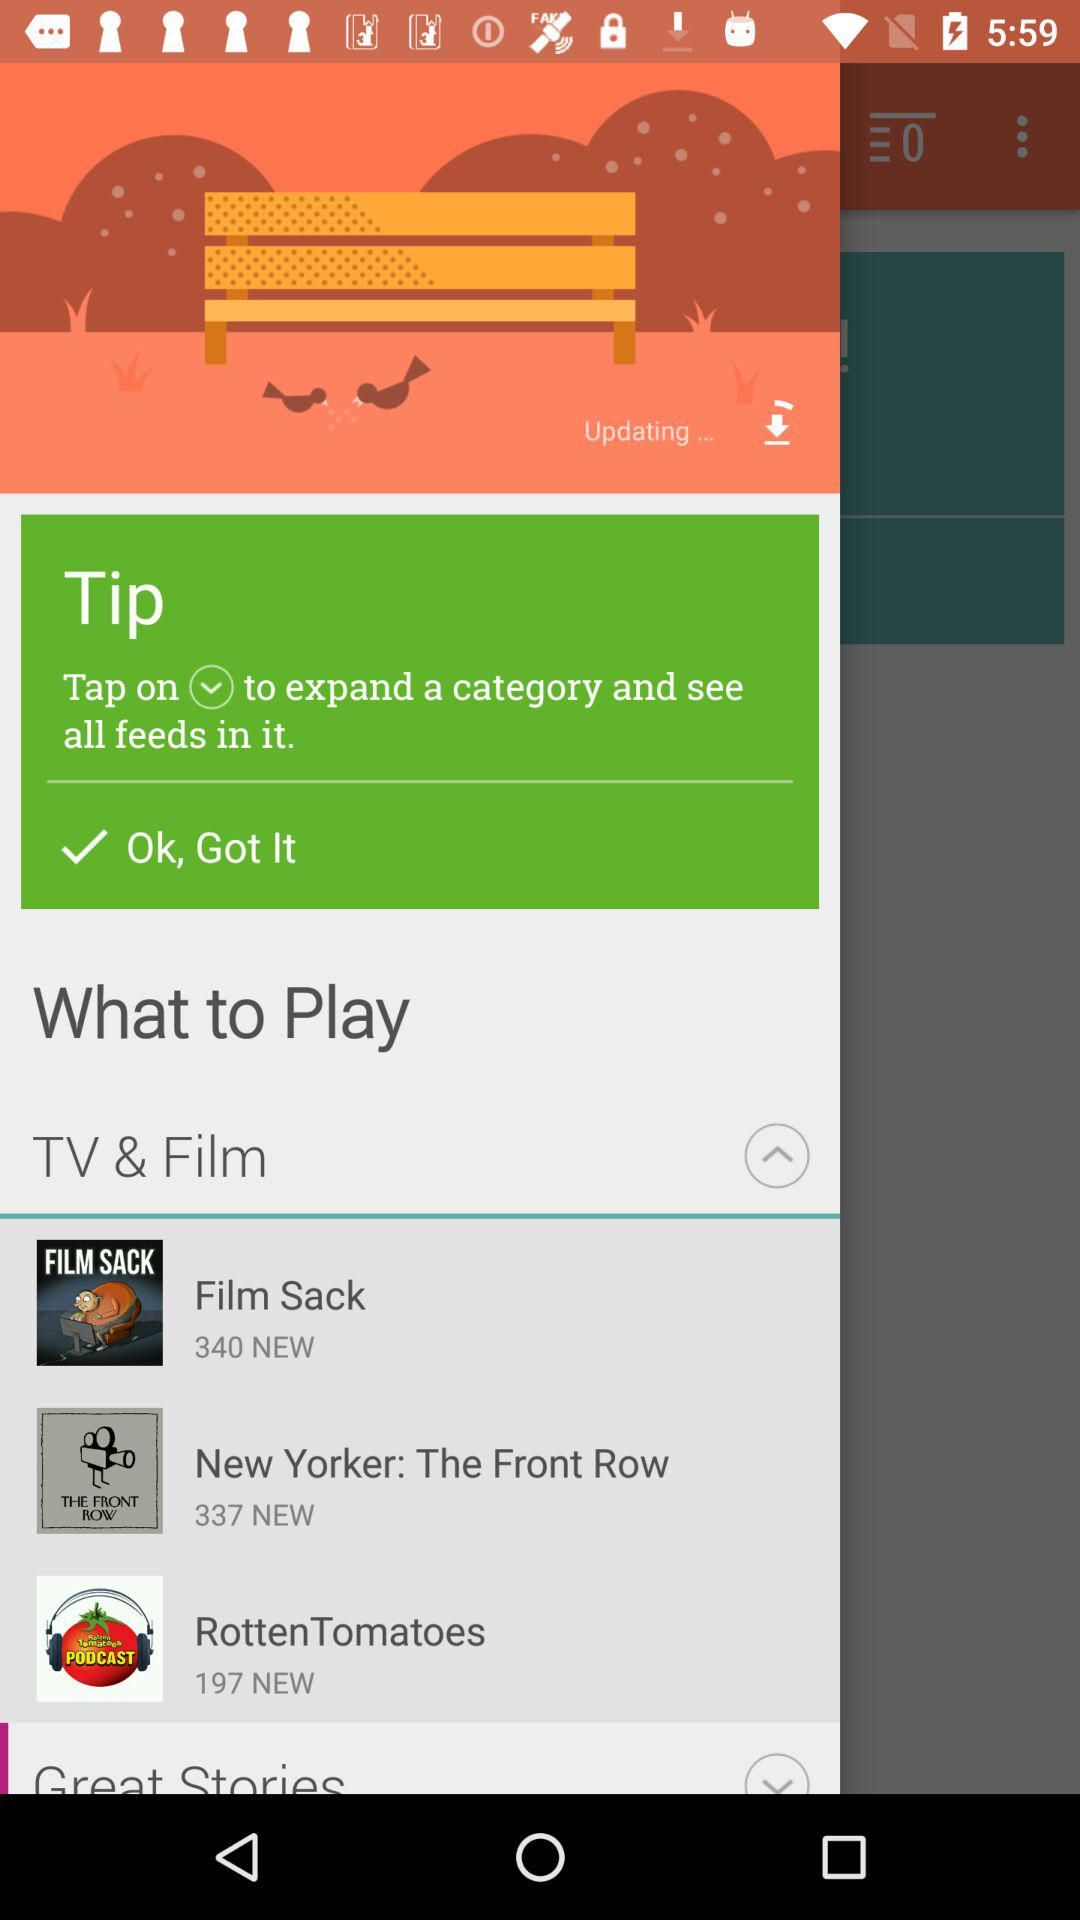What's the count of new articles in "New Yorker: The Front Row"? The count of new articles in "New Yorker: The Front Row" is 337. 